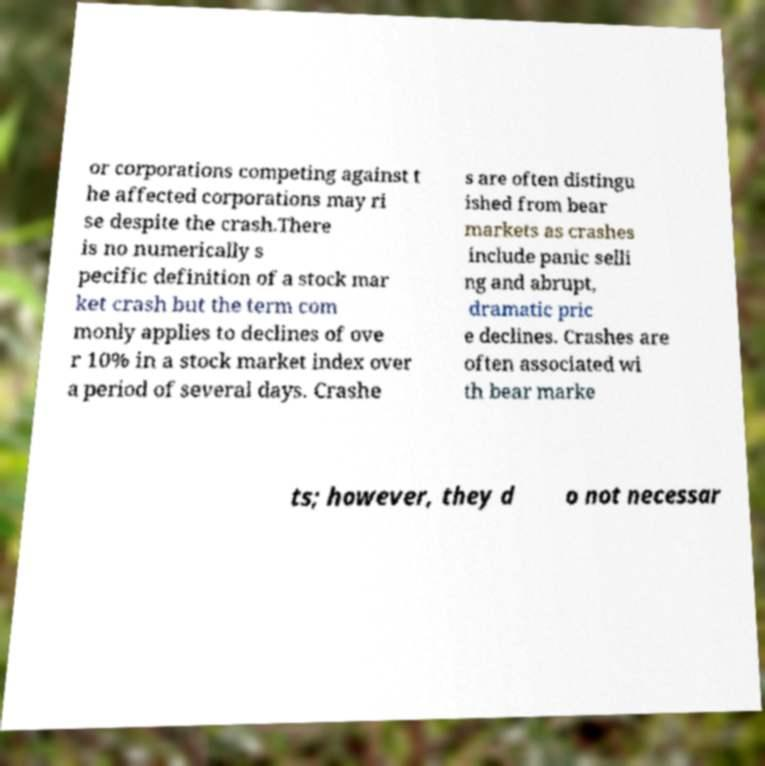Can you read and provide the text displayed in the image?This photo seems to have some interesting text. Can you extract and type it out for me? or corporations competing against t he affected corporations may ri se despite the crash.There is no numerically s pecific definition of a stock mar ket crash but the term com monly applies to declines of ove r 10% in a stock market index over a period of several days. Crashe s are often distingu ished from bear markets as crashes include panic selli ng and abrupt, dramatic pric e declines. Crashes are often associated wi th bear marke ts; however, they d o not necessar 